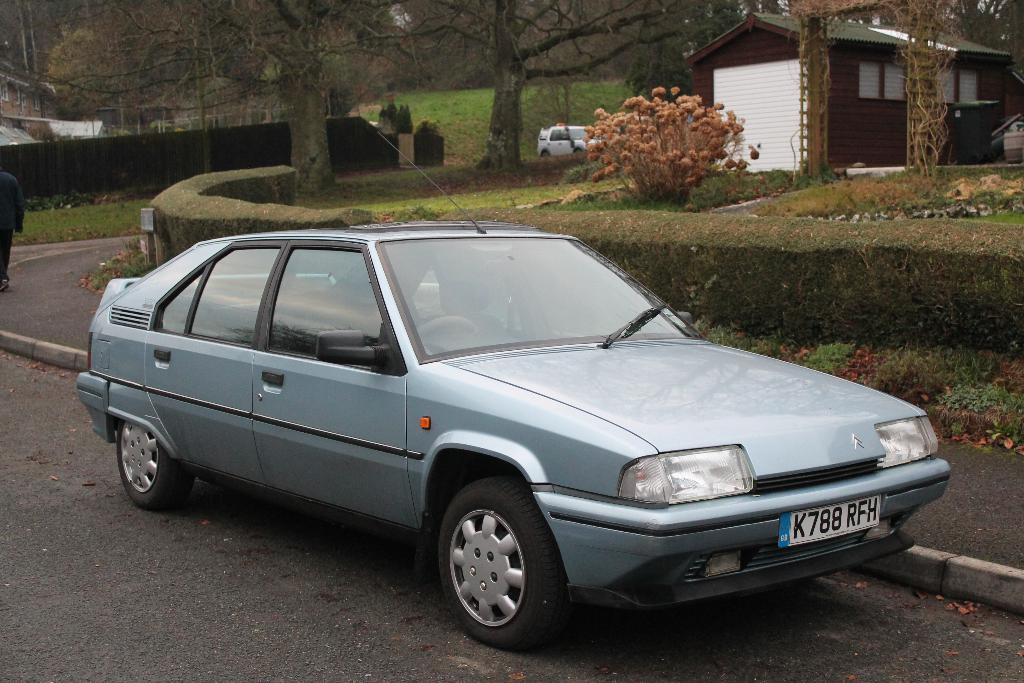What types of objects are present in the image? There are vehicles and a house in the image. Can you describe the house in the image? The house is white and brown in color. What else can be seen in the image besides the house and vehicles? There are trees and fencing in the image. What type of learning is taking place in the image? There is no indication of any learning taking place in the image. Can you describe the machine that is being used in the image? There is no machine present in the image. 